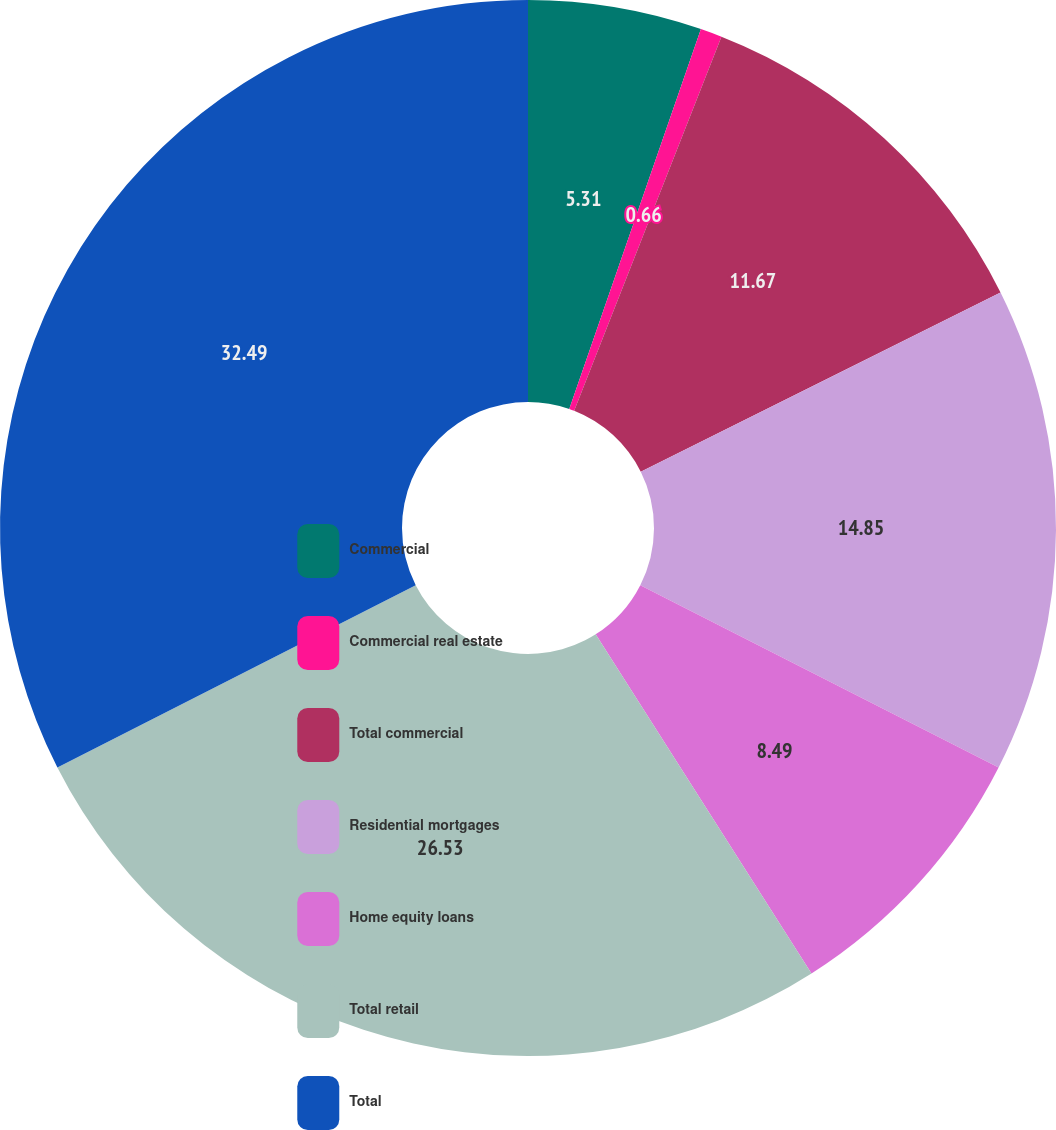Convert chart. <chart><loc_0><loc_0><loc_500><loc_500><pie_chart><fcel>Commercial<fcel>Commercial real estate<fcel>Total commercial<fcel>Residential mortgages<fcel>Home equity loans<fcel>Total retail<fcel>Total<nl><fcel>5.31%<fcel>0.66%<fcel>11.67%<fcel>14.85%<fcel>8.49%<fcel>26.53%<fcel>32.49%<nl></chart> 